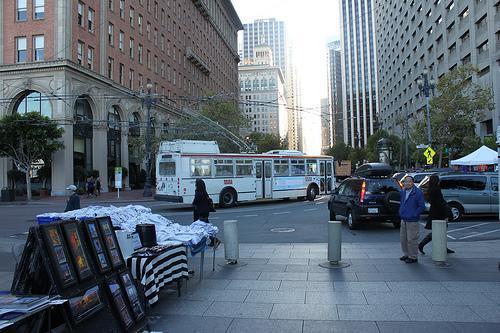How many buses?
Give a very brief answer. 1. 